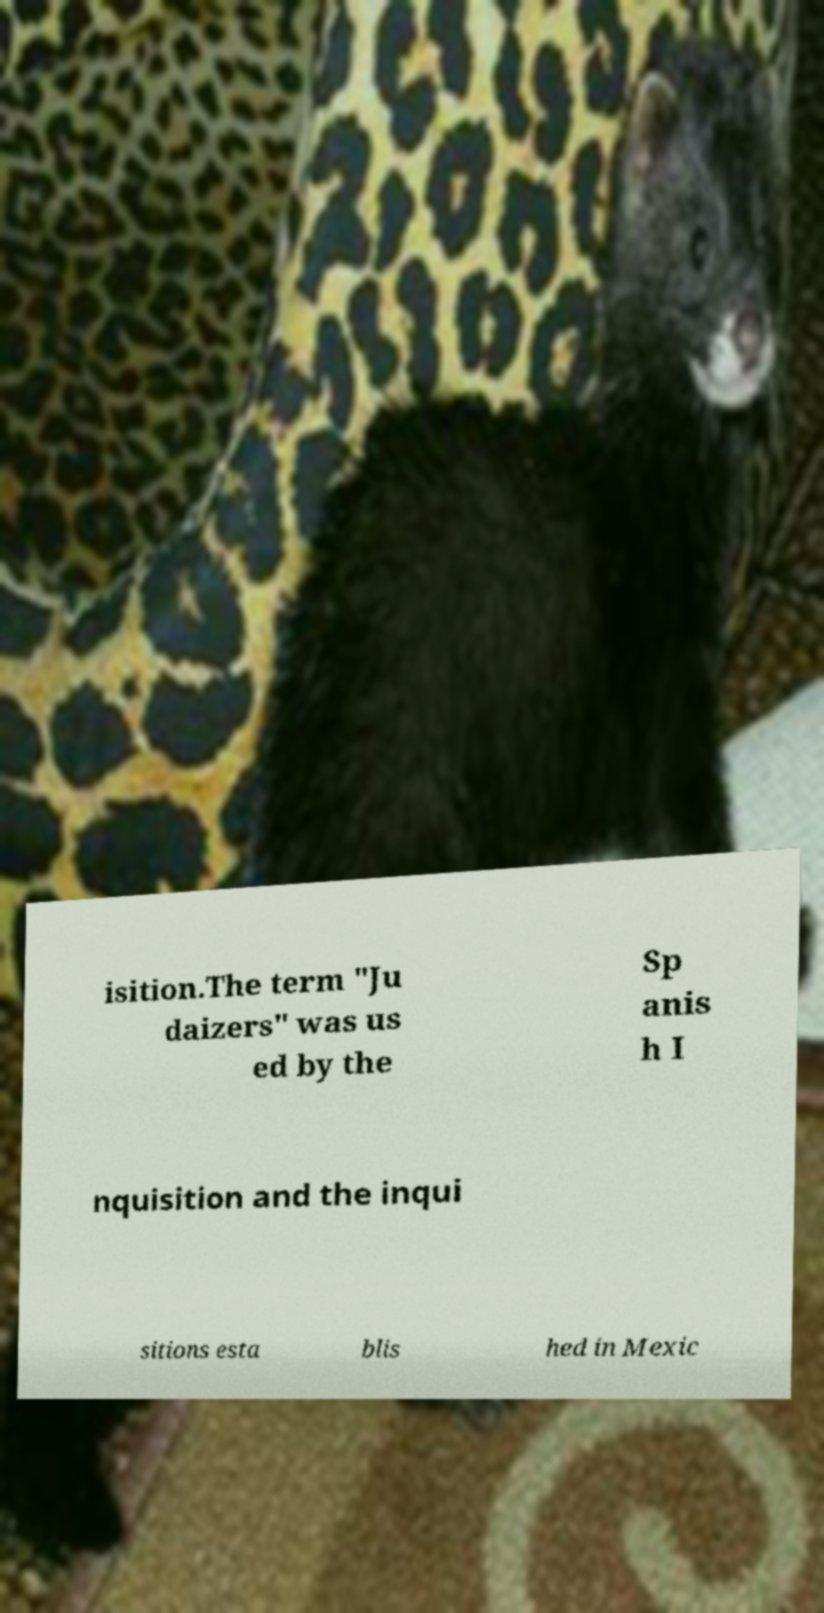There's text embedded in this image that I need extracted. Can you transcribe it verbatim? isition.The term "Ju daizers" was us ed by the Sp anis h I nquisition and the inqui sitions esta blis hed in Mexic 